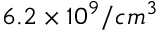Convert formula to latex. <formula><loc_0><loc_0><loc_500><loc_500>6 . 2 \times 1 0 ^ { 9 } / c m ^ { 3 }</formula> 